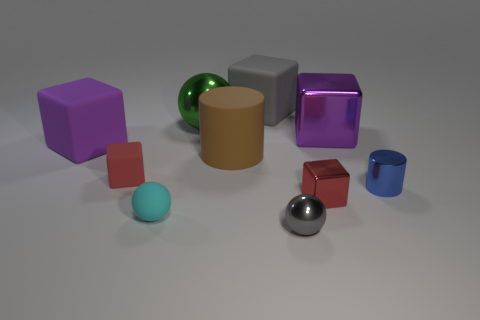Subtract all cyan balls. How many balls are left? 2 Subtract all small gray spheres. How many spheres are left? 2 Subtract 1 blue cylinders. How many objects are left? 9 Subtract all cylinders. How many objects are left? 8 Subtract 2 spheres. How many spheres are left? 1 Subtract all gray balls. Subtract all brown cubes. How many balls are left? 2 Subtract all purple blocks. How many red cylinders are left? 0 Subtract all tiny blue metallic cylinders. Subtract all gray cubes. How many objects are left? 8 Add 5 tiny gray objects. How many tiny gray objects are left? 6 Add 7 gray rubber blocks. How many gray rubber blocks exist? 8 